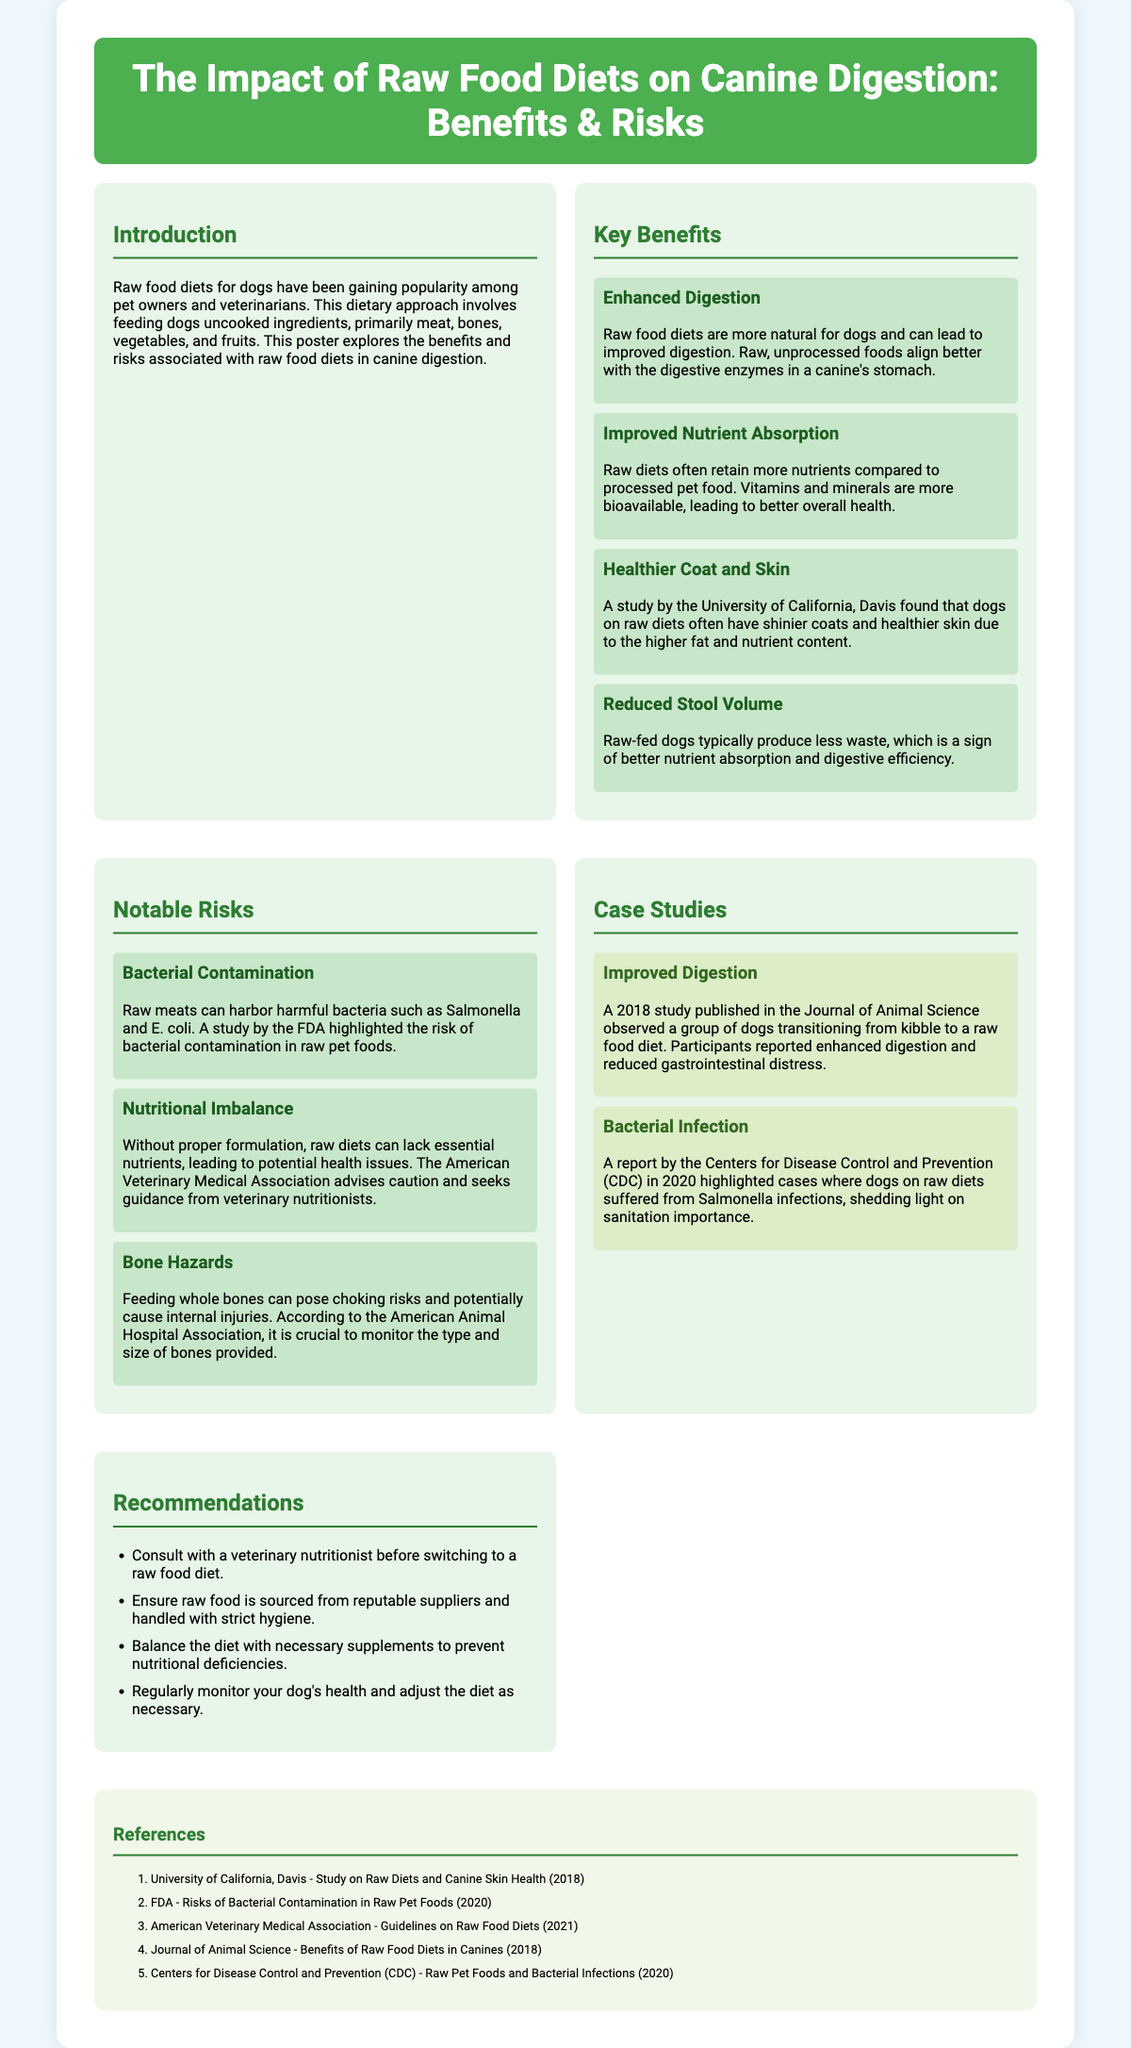What is the title of the poster? The title of the poster is provided in the header section of the document.
Answer: The Impact of Raw Food Diets on Canine Digestion: Benefits & Risks What type of diets does the poster discuss? The poster discusses raw food diets, which involve feeding uncooked ingredients to dogs.
Answer: Raw food diets Which study found that raw diets improve coat and skin health? The poster references a study conducted by a specific university regarding the impact of raw diets on dogs' coat and skin health.
Answer: University of California, Davis What can raw food diets reduce in dogs? The poster mentions a specific benefit of raw food diets related to waste production in dogs.
Answer: Stool volume What risk is associated with raw meats mentioned in the poster? The poster outlines a specific risk regarding the presence of harmful bacteria in raw meats.
Answer: Bacterial contamination Which organization advises caution when switching to raw food diets? The poster refers to a specific association that provides guidelines on raw food diets for pets.
Answer: American Veterinary Medical Association What year did the CDC highlight cases of Salmonella infections in dogs on raw diets? The specific year is noted in connection with a report on bacterial infections in dogs consuming raw diets.
Answer: 2020 How many benefits are listed in the poster? The poster lists a total of four benefits associated with raw food diets.
Answer: Four 